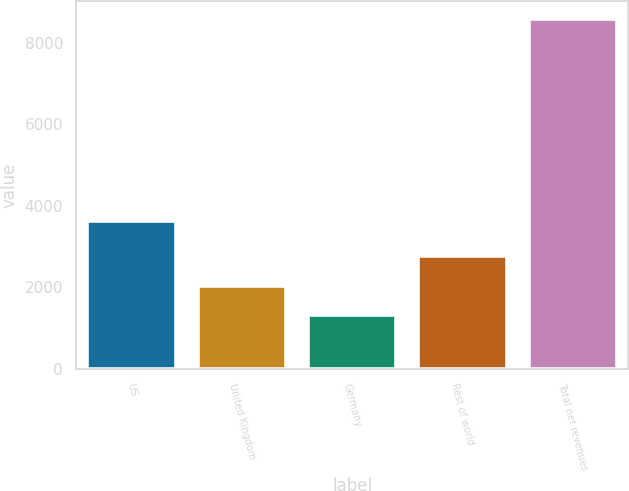Convert chart. <chart><loc_0><loc_0><loc_500><loc_500><bar_chart><fcel>US<fcel>United Kingdom<fcel>Germany<fcel>Rest of world<fcel>Total net revenues<nl><fcel>3624<fcel>2038.2<fcel>1310<fcel>2766.4<fcel>8592<nl></chart> 